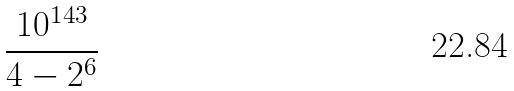<formula> <loc_0><loc_0><loc_500><loc_500>\frac { 1 0 ^ { 1 4 3 } } { 4 - 2 ^ { 6 } }</formula> 